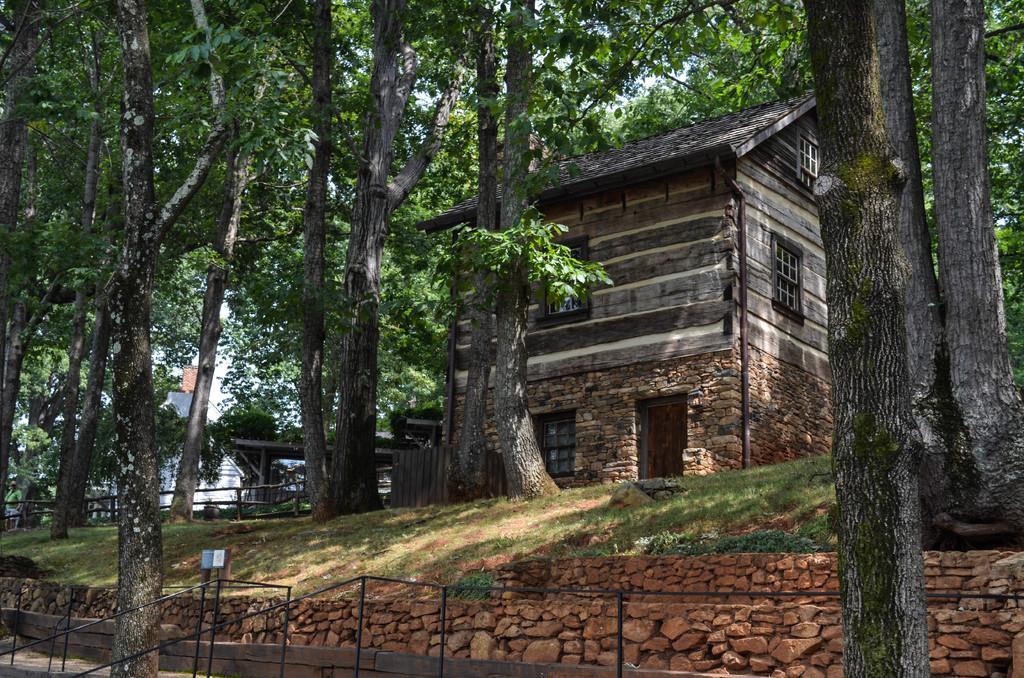Describe this image in one or two sentences. In the center of the image there is a shed and we can see trees. At the bottom there are railings and we can see grass. In the background there is sky. 